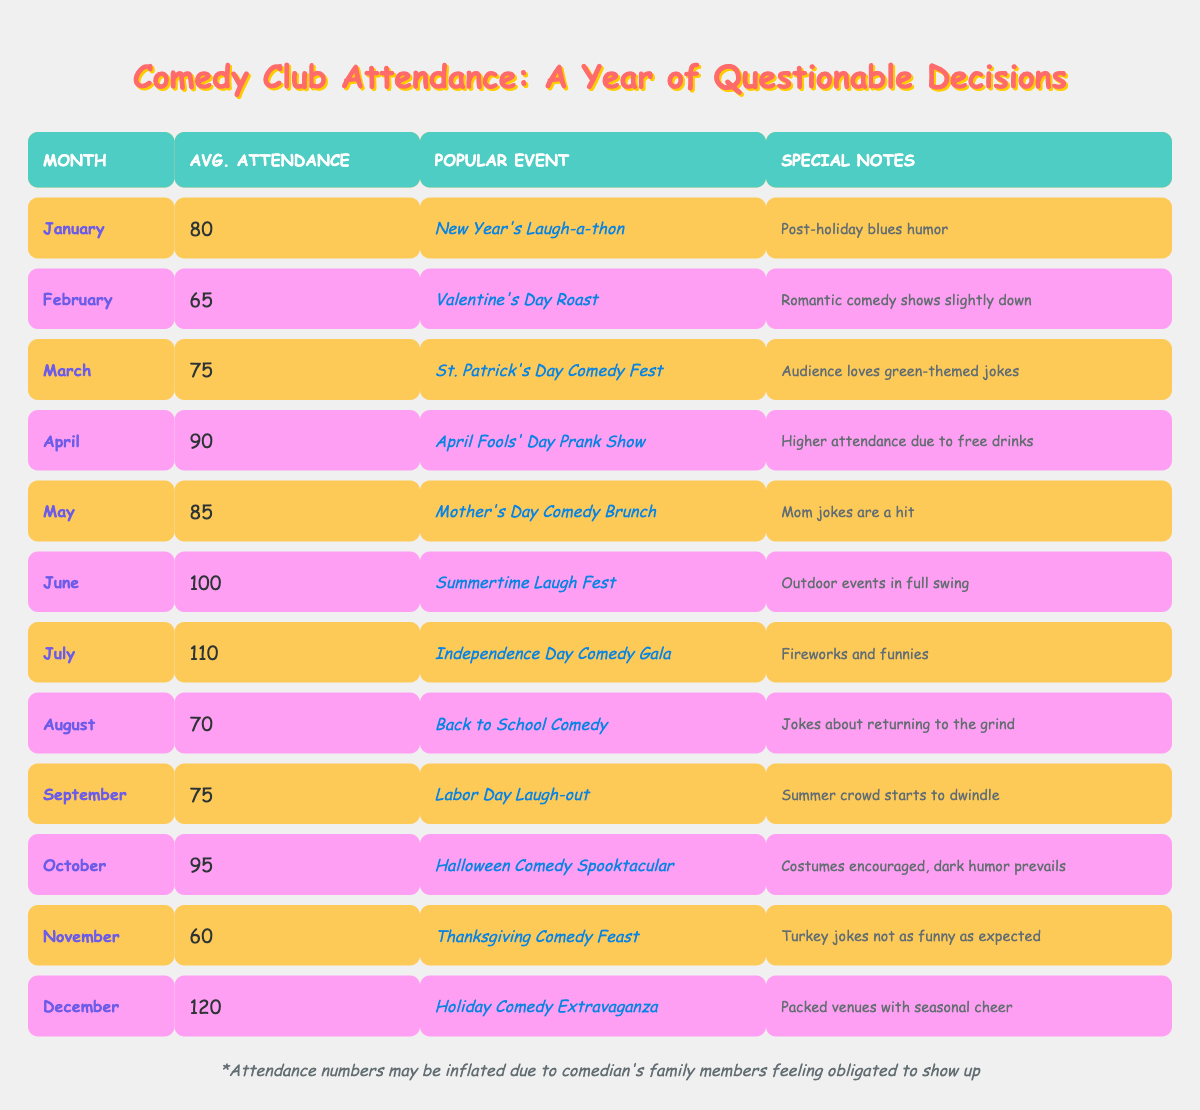What was the average attendance in June? The table shows that the average attendance in June is listed as 100.
Answer: 100 What special event occurred in July? According to the table, the popular event in July was the "Independence Day Comedy Gala."
Answer: Independence Day Comedy Gala In which month did attendance drop to its lowest level, and what was that number? By reviewing the table, February has the lowest attendance at 65.
Answer: February, 65 What is the total average attendance from April to June? I will add the average attendance values: April (90) + May (85) + June (100) = 275. Since there are three months in this range, I will divide by 3 to find the average: 275 / 3 = approximately 91.67.
Answer: Approximately 91.67 Did attendance in November exceed attendance in August? The table shows November's attendance as 60 and August's as 70; since 60 is not greater than 70, the answer is no.
Answer: No What is the difference in average attendance between the highest and lowest months? The highest average attendance is in December with 120 and the lowest is in February with 65. The difference will be calculated as 120 - 65 = 55.
Answer: 55 Which month had a notable attendance boost, and what was the reason provided? In April, attendance increased to 90 due to the "April Fools' Day Prank Show," and higher attendance was noted because of free drinks.
Answer: April, free drinks What month saw an increase in average attendance compared to the previous month? The table indicates that June (100) had greater attendance compared to May (85), showing an increase.
Answer: June If we were to arrange the months by average attendance, which month would rank third from the top? Looking at the attendance values, they are sorted as: July (110), June (100), and October (95). Thus, October ranks third among these.
Answer: October 